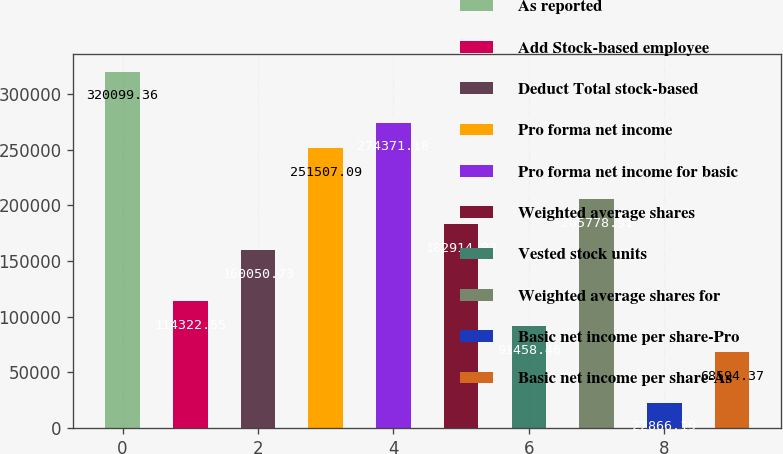Convert chart. <chart><loc_0><loc_0><loc_500><loc_500><bar_chart><fcel>As reported<fcel>Add Stock-based employee<fcel>Deduct Total stock-based<fcel>Pro forma net income<fcel>Pro forma net income for basic<fcel>Weighted average shares<fcel>Vested stock units<fcel>Weighted average shares for<fcel>Basic net income per share-Pro<fcel>Basic net income per share-As<nl><fcel>320099<fcel>114323<fcel>160051<fcel>251507<fcel>274371<fcel>182915<fcel>91458.5<fcel>205779<fcel>22866.2<fcel>68594.4<nl></chart> 